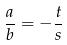<formula> <loc_0><loc_0><loc_500><loc_500>\frac { a } { b } = - \frac { t } { s }</formula> 